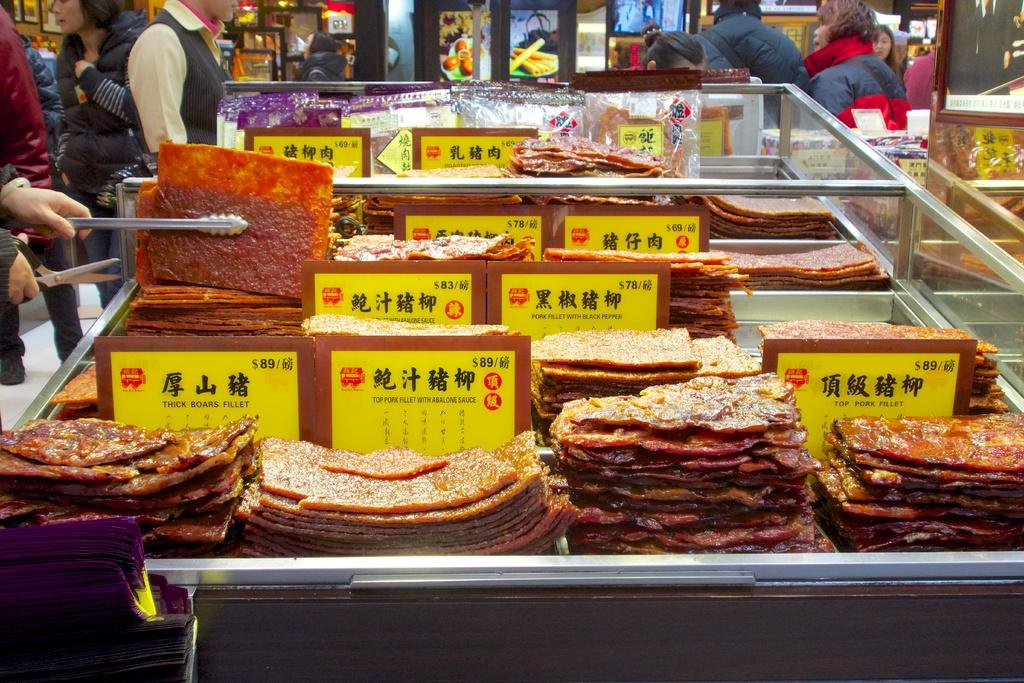What type of objects can be seen in the image? There are food items in the image. How are the food items arranged or stored? The food items are kept in a rack. What other objects can be seen in the image besides the food items? There are boards and many persons visible in the image. What can be seen on the wall in the background? There are frames on the wall in the background. What type of cabbage can be seen growing on the railway tracks in the image? There is no cabbage or railway tracks present in the image. Can you describe the lipstick color of the person in the image? There is no mention of lipstick or any person's lips in the provided facts, so it cannot be determined from the image. 